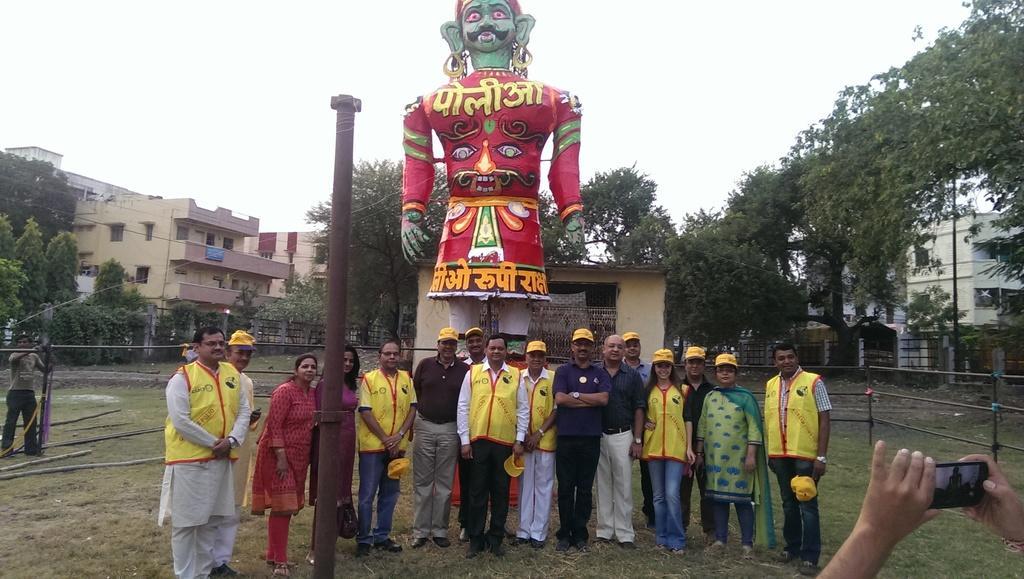Can you describe this image briefly? In this image we can see few persons are standing and among them few persons are holding caps and bags in their hands. In the background we can see buildings, poles, fences, trees, plants, statue and the sky. On the right side at the bottom corner we can see a person's hands holding a mobile in the hands and capturing pics. 